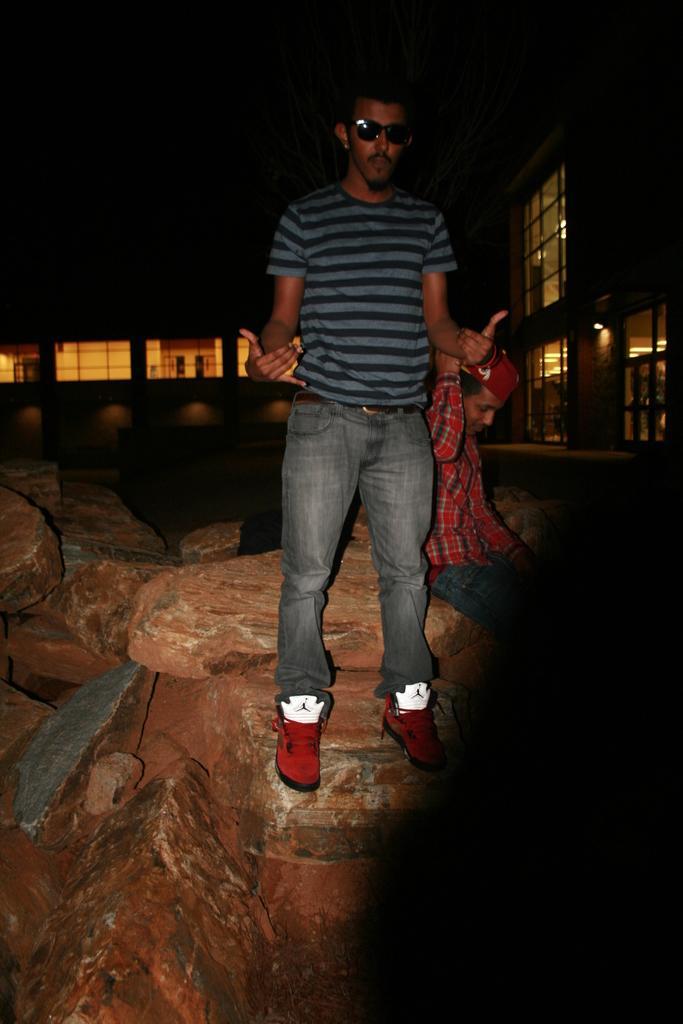In one or two sentences, can you explain what this image depicts? In the center of the image there is a person standing on the rocks. There is another person sitting behind him. In the background of the image there are buildings, lights. 